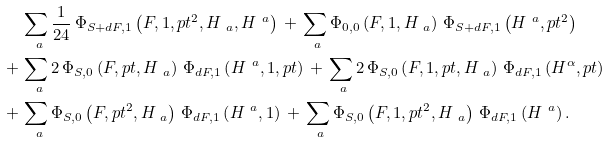Convert formula to latex. <formula><loc_0><loc_0><loc_500><loc_500>& \sum _ { \ a } \frac { 1 } { 2 4 } \, \Phi _ { S + d F , 1 } \left ( F , 1 , p t ^ { 2 } , H _ { \ a } , H ^ { \ a } \right ) \, + \, \sum _ { \ a } \Phi _ { 0 , 0 } \left ( F , 1 , H _ { \ a } \right ) \, \Phi _ { S + d F , 1 } \left ( H ^ { \ a } , p t ^ { 2 } \right ) \\ + \, & \sum _ { \ a } 2 \, \Phi _ { S , 0 } \left ( F , p t , H _ { \ a } \right ) \, \Phi _ { d F , 1 } \left ( H ^ { \ a } , 1 , p t \right ) \, + \, \sum _ { \ a } 2 \, \Phi _ { S , 0 } \left ( F , 1 , p t , H _ { \ a } \right ) \, \Phi _ { d F , 1 } \left ( H ^ { \alpha } , p t \right ) \\ + \, & \sum _ { \ a } \Phi _ { S , 0 } \left ( F , p t ^ { 2 } , H _ { \ a } \right ) \, \Phi _ { d F , 1 } \left ( H ^ { \ a } , 1 \right ) \, + \, \sum _ { \ a } \Phi _ { S , 0 } \left ( F , 1 , p t ^ { 2 } , H _ { \ a } \right ) \, \Phi _ { d F , 1 } \left ( H ^ { \ a } \right ) .</formula> 